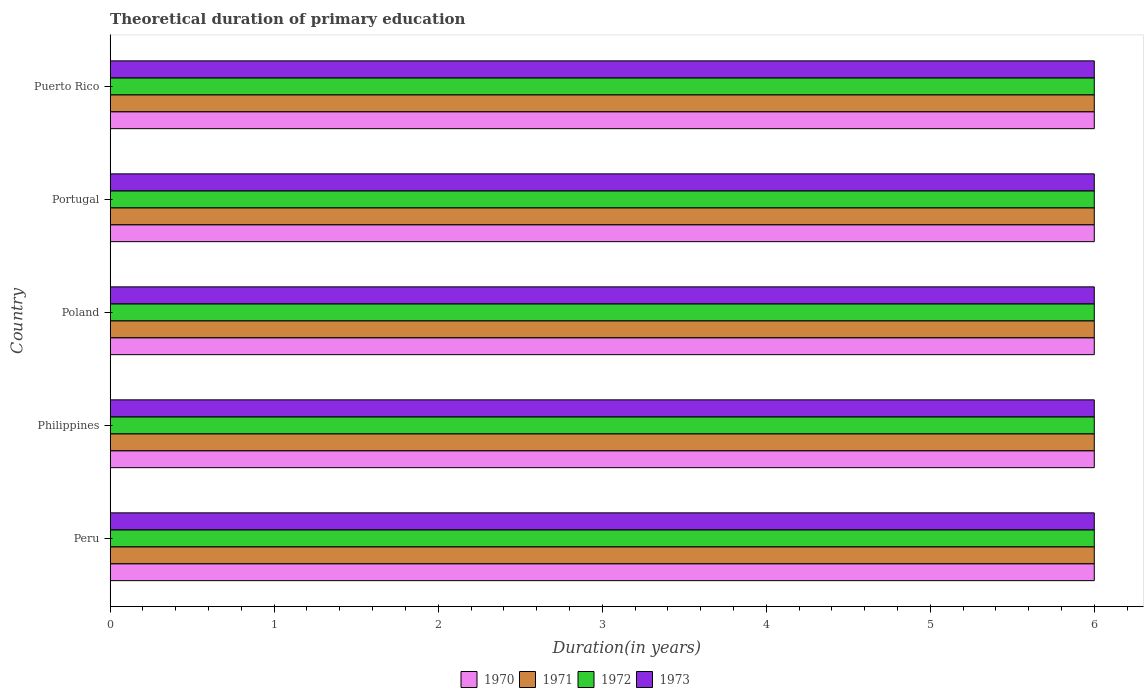Are the number of bars per tick equal to the number of legend labels?
Provide a short and direct response. Yes. How many bars are there on the 1st tick from the bottom?
Provide a short and direct response. 4. In how many cases, is the number of bars for a given country not equal to the number of legend labels?
Provide a succinct answer. 0. Across all countries, what is the minimum total theoretical duration of primary education in 1973?
Provide a short and direct response. 6. In which country was the total theoretical duration of primary education in 1970 maximum?
Offer a terse response. Peru. What is the difference between the total theoretical duration of primary education in 1973 in Philippines and that in Poland?
Your answer should be very brief. 0. What is the average total theoretical duration of primary education in 1971 per country?
Your response must be concise. 6. What is the ratio of the total theoretical duration of primary education in 1970 in Philippines to that in Puerto Rico?
Give a very brief answer. 1. Is the difference between the total theoretical duration of primary education in 1973 in Philippines and Puerto Rico greater than the difference between the total theoretical duration of primary education in 1972 in Philippines and Puerto Rico?
Your answer should be compact. No. What is the difference between the highest and the lowest total theoretical duration of primary education in 1973?
Your answer should be compact. 0. Is the sum of the total theoretical duration of primary education in 1971 in Philippines and Puerto Rico greater than the maximum total theoretical duration of primary education in 1972 across all countries?
Provide a short and direct response. Yes. What does the 1st bar from the bottom in Philippines represents?
Offer a terse response. 1970. How many countries are there in the graph?
Make the answer very short. 5. What is the difference between two consecutive major ticks on the X-axis?
Your response must be concise. 1. Are the values on the major ticks of X-axis written in scientific E-notation?
Offer a very short reply. No. Does the graph contain any zero values?
Make the answer very short. No. Where does the legend appear in the graph?
Give a very brief answer. Bottom center. What is the title of the graph?
Provide a short and direct response. Theoretical duration of primary education. What is the label or title of the X-axis?
Keep it short and to the point. Duration(in years). What is the label or title of the Y-axis?
Ensure brevity in your answer.  Country. What is the Duration(in years) of 1971 in Peru?
Your answer should be compact. 6. What is the Duration(in years) in 1970 in Philippines?
Offer a very short reply. 6. What is the Duration(in years) of 1970 in Poland?
Provide a short and direct response. 6. What is the Duration(in years) in 1971 in Poland?
Offer a very short reply. 6. What is the Duration(in years) in 1972 in Poland?
Make the answer very short. 6. What is the Duration(in years) of 1973 in Poland?
Your answer should be compact. 6. What is the Duration(in years) in 1970 in Portugal?
Ensure brevity in your answer.  6. What is the Duration(in years) of 1970 in Puerto Rico?
Offer a very short reply. 6. What is the Duration(in years) of 1971 in Puerto Rico?
Your answer should be compact. 6. What is the Duration(in years) in 1973 in Puerto Rico?
Offer a terse response. 6. Across all countries, what is the maximum Duration(in years) in 1970?
Make the answer very short. 6. Across all countries, what is the maximum Duration(in years) of 1972?
Ensure brevity in your answer.  6. Across all countries, what is the minimum Duration(in years) in 1970?
Your answer should be very brief. 6. Across all countries, what is the minimum Duration(in years) in 1972?
Offer a terse response. 6. What is the total Duration(in years) in 1970 in the graph?
Give a very brief answer. 30. What is the total Duration(in years) in 1971 in the graph?
Provide a short and direct response. 30. What is the total Duration(in years) in 1973 in the graph?
Make the answer very short. 30. What is the difference between the Duration(in years) in 1970 in Peru and that in Philippines?
Offer a very short reply. 0. What is the difference between the Duration(in years) of 1971 in Peru and that in Philippines?
Keep it short and to the point. 0. What is the difference between the Duration(in years) in 1972 in Peru and that in Philippines?
Your answer should be very brief. 0. What is the difference between the Duration(in years) in 1973 in Peru and that in Philippines?
Offer a terse response. 0. What is the difference between the Duration(in years) in 1971 in Peru and that in Poland?
Keep it short and to the point. 0. What is the difference between the Duration(in years) in 1972 in Peru and that in Poland?
Provide a short and direct response. 0. What is the difference between the Duration(in years) of 1970 in Peru and that in Portugal?
Your response must be concise. 0. What is the difference between the Duration(in years) of 1971 in Peru and that in Portugal?
Your answer should be compact. 0. What is the difference between the Duration(in years) of 1970 in Peru and that in Puerto Rico?
Your answer should be very brief. 0. What is the difference between the Duration(in years) of 1971 in Peru and that in Puerto Rico?
Give a very brief answer. 0. What is the difference between the Duration(in years) of 1973 in Peru and that in Puerto Rico?
Ensure brevity in your answer.  0. What is the difference between the Duration(in years) in 1971 in Philippines and that in Poland?
Your answer should be compact. 0. What is the difference between the Duration(in years) in 1971 in Philippines and that in Portugal?
Provide a short and direct response. 0. What is the difference between the Duration(in years) in 1972 in Philippines and that in Portugal?
Offer a very short reply. 0. What is the difference between the Duration(in years) of 1970 in Philippines and that in Puerto Rico?
Offer a very short reply. 0. What is the difference between the Duration(in years) in 1971 in Philippines and that in Puerto Rico?
Make the answer very short. 0. What is the difference between the Duration(in years) in 1973 in Philippines and that in Puerto Rico?
Give a very brief answer. 0. What is the difference between the Duration(in years) in 1970 in Poland and that in Portugal?
Provide a succinct answer. 0. What is the difference between the Duration(in years) of 1971 in Poland and that in Portugal?
Make the answer very short. 0. What is the difference between the Duration(in years) of 1973 in Poland and that in Portugal?
Keep it short and to the point. 0. What is the difference between the Duration(in years) of 1970 in Poland and that in Puerto Rico?
Make the answer very short. 0. What is the difference between the Duration(in years) of 1971 in Poland and that in Puerto Rico?
Your answer should be very brief. 0. What is the difference between the Duration(in years) in 1971 in Portugal and that in Puerto Rico?
Give a very brief answer. 0. What is the difference between the Duration(in years) of 1972 in Portugal and that in Puerto Rico?
Provide a short and direct response. 0. What is the difference between the Duration(in years) of 1970 in Peru and the Duration(in years) of 1971 in Philippines?
Offer a terse response. 0. What is the difference between the Duration(in years) of 1970 in Peru and the Duration(in years) of 1972 in Philippines?
Provide a short and direct response. 0. What is the difference between the Duration(in years) of 1970 in Peru and the Duration(in years) of 1971 in Poland?
Offer a very short reply. 0. What is the difference between the Duration(in years) of 1971 in Peru and the Duration(in years) of 1972 in Poland?
Provide a short and direct response. 0. What is the difference between the Duration(in years) in 1970 in Peru and the Duration(in years) in 1971 in Portugal?
Make the answer very short. 0. What is the difference between the Duration(in years) of 1971 in Peru and the Duration(in years) of 1972 in Portugal?
Give a very brief answer. 0. What is the difference between the Duration(in years) of 1972 in Peru and the Duration(in years) of 1973 in Portugal?
Your response must be concise. 0. What is the difference between the Duration(in years) in 1970 in Peru and the Duration(in years) in 1972 in Puerto Rico?
Offer a terse response. 0. What is the difference between the Duration(in years) of 1971 in Peru and the Duration(in years) of 1972 in Puerto Rico?
Your answer should be compact. 0. What is the difference between the Duration(in years) of 1971 in Peru and the Duration(in years) of 1973 in Puerto Rico?
Offer a very short reply. 0. What is the difference between the Duration(in years) of 1970 in Philippines and the Duration(in years) of 1972 in Poland?
Provide a succinct answer. 0. What is the difference between the Duration(in years) in 1970 in Philippines and the Duration(in years) in 1972 in Portugal?
Make the answer very short. 0. What is the difference between the Duration(in years) in 1970 in Philippines and the Duration(in years) in 1973 in Portugal?
Your response must be concise. 0. What is the difference between the Duration(in years) in 1971 in Philippines and the Duration(in years) in 1972 in Portugal?
Make the answer very short. 0. What is the difference between the Duration(in years) in 1971 in Philippines and the Duration(in years) in 1973 in Portugal?
Give a very brief answer. 0. What is the difference between the Duration(in years) in 1972 in Philippines and the Duration(in years) in 1973 in Portugal?
Give a very brief answer. 0. What is the difference between the Duration(in years) of 1970 in Philippines and the Duration(in years) of 1971 in Puerto Rico?
Give a very brief answer. 0. What is the difference between the Duration(in years) of 1972 in Philippines and the Duration(in years) of 1973 in Puerto Rico?
Your response must be concise. 0. What is the difference between the Duration(in years) in 1970 in Poland and the Duration(in years) in 1971 in Portugal?
Provide a short and direct response. 0. What is the difference between the Duration(in years) in 1971 in Poland and the Duration(in years) in 1973 in Portugal?
Your response must be concise. 0. What is the difference between the Duration(in years) in 1970 in Poland and the Duration(in years) in 1971 in Puerto Rico?
Give a very brief answer. 0. What is the difference between the Duration(in years) of 1970 in Poland and the Duration(in years) of 1972 in Puerto Rico?
Give a very brief answer. 0. What is the difference between the Duration(in years) of 1971 in Poland and the Duration(in years) of 1972 in Puerto Rico?
Your response must be concise. 0. What is the difference between the Duration(in years) of 1971 in Poland and the Duration(in years) of 1973 in Puerto Rico?
Make the answer very short. 0. What is the difference between the Duration(in years) of 1972 in Poland and the Duration(in years) of 1973 in Puerto Rico?
Offer a very short reply. 0. What is the difference between the Duration(in years) of 1970 in Portugal and the Duration(in years) of 1971 in Puerto Rico?
Your response must be concise. 0. What is the difference between the Duration(in years) of 1971 in Portugal and the Duration(in years) of 1972 in Puerto Rico?
Give a very brief answer. 0. What is the average Duration(in years) in 1970 per country?
Offer a terse response. 6. What is the average Duration(in years) of 1971 per country?
Offer a very short reply. 6. What is the average Duration(in years) of 1973 per country?
Make the answer very short. 6. What is the difference between the Duration(in years) of 1970 and Duration(in years) of 1973 in Peru?
Keep it short and to the point. 0. What is the difference between the Duration(in years) of 1971 and Duration(in years) of 1972 in Peru?
Provide a short and direct response. 0. What is the difference between the Duration(in years) of 1970 and Duration(in years) of 1971 in Philippines?
Make the answer very short. 0. What is the difference between the Duration(in years) in 1970 and Duration(in years) in 1972 in Philippines?
Your answer should be very brief. 0. What is the difference between the Duration(in years) in 1971 and Duration(in years) in 1972 in Philippines?
Your answer should be compact. 0. What is the difference between the Duration(in years) of 1970 and Duration(in years) of 1971 in Poland?
Provide a succinct answer. 0. What is the difference between the Duration(in years) in 1970 and Duration(in years) in 1972 in Poland?
Provide a short and direct response. 0. What is the difference between the Duration(in years) of 1970 and Duration(in years) of 1973 in Poland?
Keep it short and to the point. 0. What is the difference between the Duration(in years) of 1971 and Duration(in years) of 1972 in Poland?
Keep it short and to the point. 0. What is the difference between the Duration(in years) in 1971 and Duration(in years) in 1973 in Poland?
Offer a terse response. 0. What is the difference between the Duration(in years) in 1972 and Duration(in years) in 1973 in Poland?
Provide a short and direct response. 0. What is the difference between the Duration(in years) of 1971 and Duration(in years) of 1972 in Portugal?
Your answer should be compact. 0. What is the difference between the Duration(in years) of 1972 and Duration(in years) of 1973 in Portugal?
Give a very brief answer. 0. What is the difference between the Duration(in years) in 1970 and Duration(in years) in 1971 in Puerto Rico?
Offer a terse response. 0. What is the difference between the Duration(in years) in 1970 and Duration(in years) in 1972 in Puerto Rico?
Provide a short and direct response. 0. What is the difference between the Duration(in years) of 1971 and Duration(in years) of 1973 in Puerto Rico?
Your answer should be very brief. 0. What is the difference between the Duration(in years) of 1972 and Duration(in years) of 1973 in Puerto Rico?
Ensure brevity in your answer.  0. What is the ratio of the Duration(in years) in 1971 in Peru to that in Poland?
Offer a very short reply. 1. What is the ratio of the Duration(in years) in 1972 in Peru to that in Poland?
Provide a short and direct response. 1. What is the ratio of the Duration(in years) of 1973 in Peru to that in Poland?
Your answer should be compact. 1. What is the ratio of the Duration(in years) in 1972 in Peru to that in Portugal?
Provide a succinct answer. 1. What is the ratio of the Duration(in years) in 1973 in Peru to that in Portugal?
Ensure brevity in your answer.  1. What is the ratio of the Duration(in years) of 1970 in Peru to that in Puerto Rico?
Offer a terse response. 1. What is the ratio of the Duration(in years) in 1970 in Philippines to that in Poland?
Ensure brevity in your answer.  1. What is the ratio of the Duration(in years) in 1970 in Philippines to that in Portugal?
Your answer should be very brief. 1. What is the ratio of the Duration(in years) in 1971 in Philippines to that in Portugal?
Ensure brevity in your answer.  1. What is the ratio of the Duration(in years) of 1972 in Philippines to that in Portugal?
Your answer should be very brief. 1. What is the ratio of the Duration(in years) of 1971 in Philippines to that in Puerto Rico?
Provide a short and direct response. 1. What is the ratio of the Duration(in years) of 1972 in Philippines to that in Puerto Rico?
Provide a succinct answer. 1. What is the ratio of the Duration(in years) of 1973 in Philippines to that in Puerto Rico?
Ensure brevity in your answer.  1. What is the ratio of the Duration(in years) in 1970 in Poland to that in Portugal?
Provide a succinct answer. 1. What is the ratio of the Duration(in years) of 1972 in Poland to that in Portugal?
Give a very brief answer. 1. What is the ratio of the Duration(in years) in 1973 in Poland to that in Portugal?
Provide a short and direct response. 1. What is the ratio of the Duration(in years) of 1973 in Poland to that in Puerto Rico?
Ensure brevity in your answer.  1. What is the ratio of the Duration(in years) of 1970 in Portugal to that in Puerto Rico?
Your response must be concise. 1. What is the ratio of the Duration(in years) of 1971 in Portugal to that in Puerto Rico?
Provide a short and direct response. 1. What is the ratio of the Duration(in years) in 1972 in Portugal to that in Puerto Rico?
Your answer should be compact. 1. What is the ratio of the Duration(in years) of 1973 in Portugal to that in Puerto Rico?
Offer a terse response. 1. What is the difference between the highest and the second highest Duration(in years) of 1971?
Your answer should be very brief. 0. What is the difference between the highest and the second highest Duration(in years) in 1972?
Keep it short and to the point. 0. 